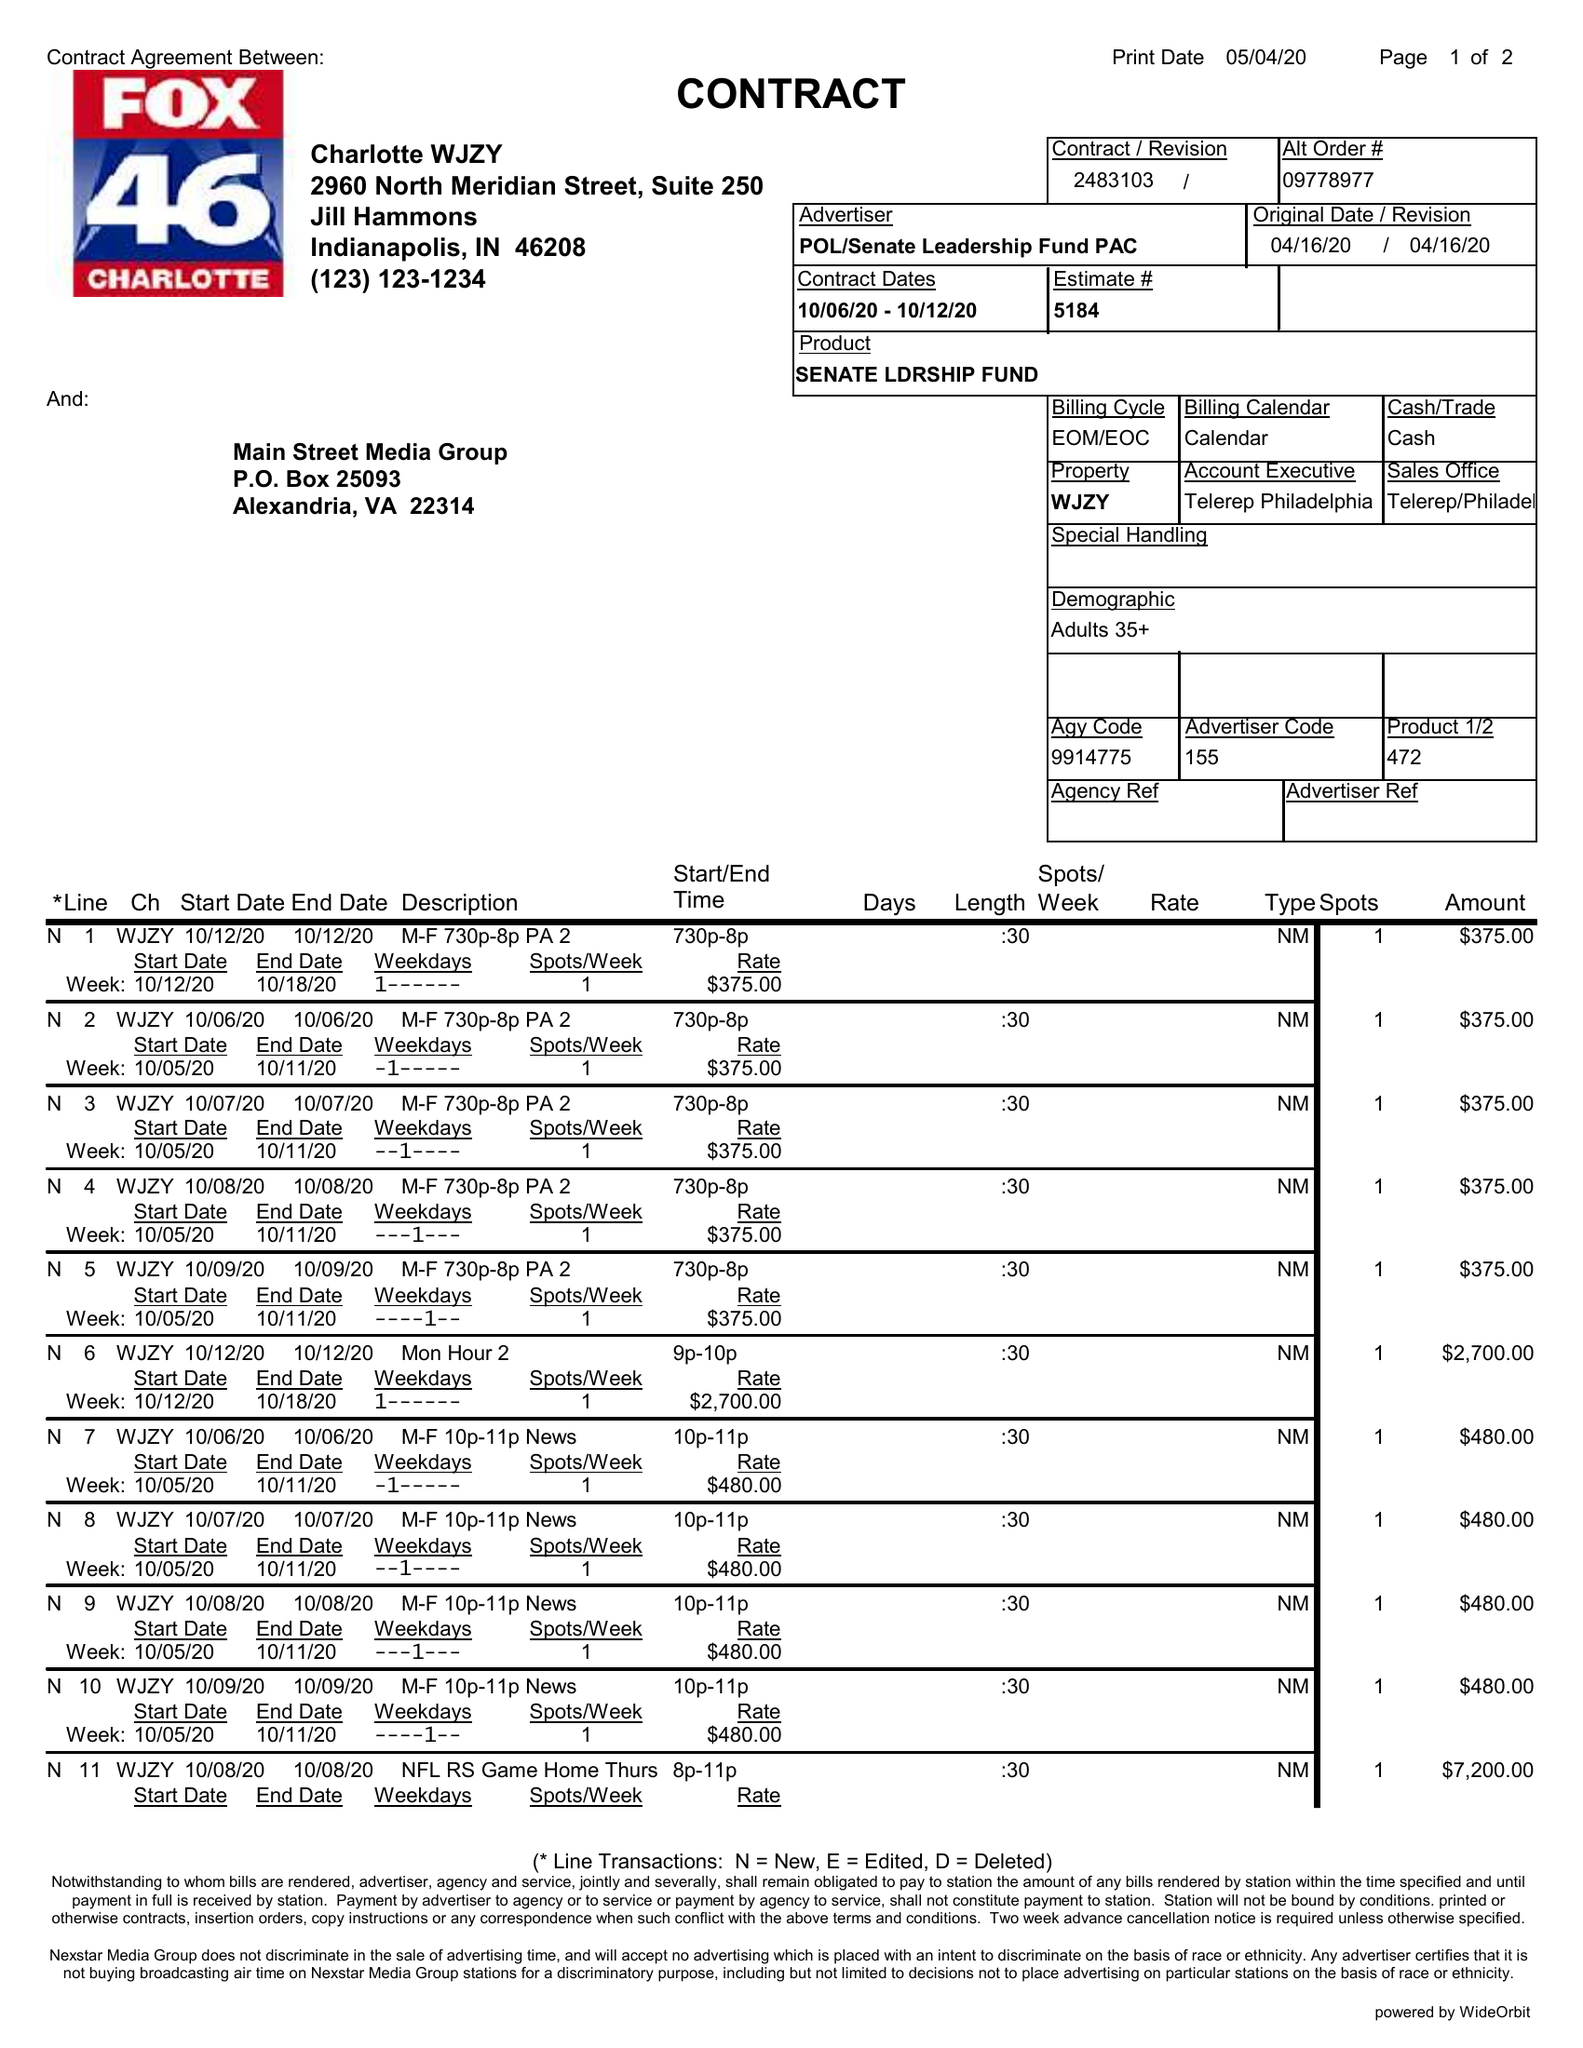What is the value for the contract_num?
Answer the question using a single word or phrase. 2483103 